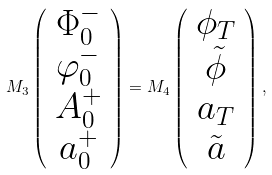Convert formula to latex. <formula><loc_0><loc_0><loc_500><loc_500>M _ { 3 } \left ( \begin{array} { c } \Phi _ { 0 } ^ { - } \\ \varphi _ { 0 } ^ { - } \\ A _ { 0 } ^ { + } \\ a _ { 0 } ^ { + } \end{array} \right ) = M _ { 4 } \left ( \begin{array} { c } \phi _ { T } \\ \tilde { \phi } \\ a _ { T } \\ \tilde { a } \end{array} \right ) ,</formula> 